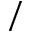<formula> <loc_0><loc_0><loc_500><loc_500>/</formula> 